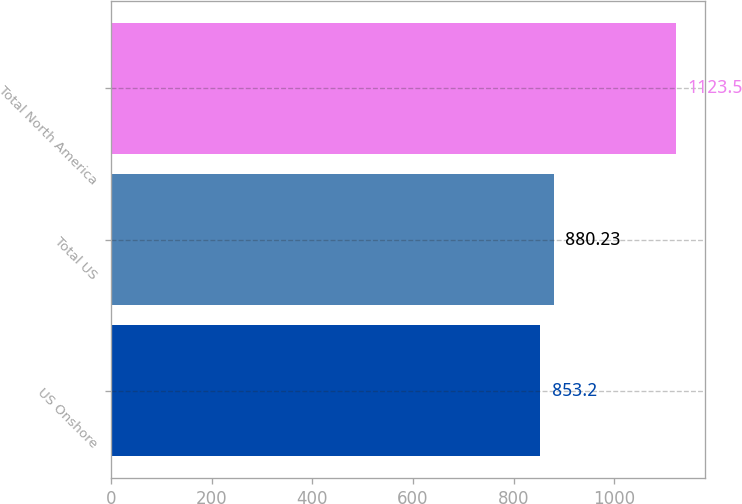Convert chart to OTSL. <chart><loc_0><loc_0><loc_500><loc_500><bar_chart><fcel>US Onshore<fcel>Total US<fcel>Total North America<nl><fcel>853.2<fcel>880.23<fcel>1123.5<nl></chart> 